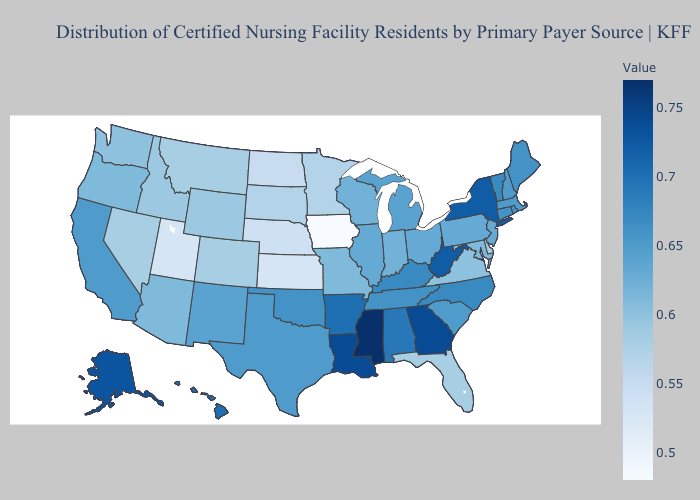Does Mississippi have the highest value in the USA?
Answer briefly. Yes. Does Iowa have the lowest value in the MidWest?
Answer briefly. Yes. Does Mississippi have the highest value in the USA?
Quick response, please. Yes. Is the legend a continuous bar?
Keep it brief. Yes. Which states have the lowest value in the USA?
Give a very brief answer. Iowa. Is the legend a continuous bar?
Answer briefly. Yes. Does Alaska have the lowest value in the West?
Give a very brief answer. No. Does Connecticut have the highest value in the Northeast?
Answer briefly. No. 